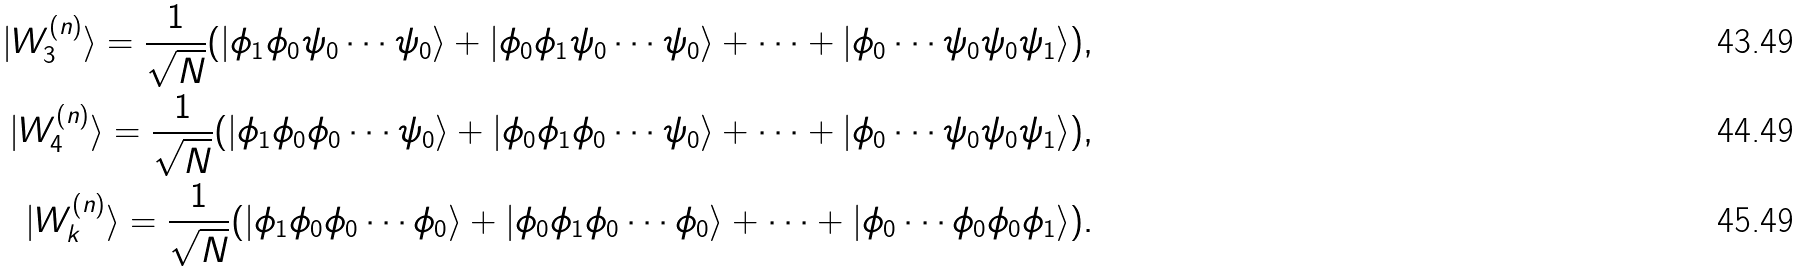Convert formula to latex. <formula><loc_0><loc_0><loc_500><loc_500>| { W } ^ { ( n ) } _ { 3 } \rangle = \frac { 1 } { \sqrt { N } } ( | \phi _ { 1 } \phi _ { 0 } \psi _ { 0 } \cdots \psi _ { 0 } \rangle + | \phi _ { 0 } \phi _ { 1 } \psi _ { 0 } \cdots \psi _ { 0 } \rangle + \cdots + | \phi _ { 0 } \cdots \psi _ { 0 } \psi _ { 0 } \psi _ { 1 } \rangle ) , \\ | { W } ^ { ( n ) } _ { 4 } \rangle = \frac { 1 } { \sqrt { N } } ( | \phi _ { 1 } \phi _ { 0 } \phi _ { 0 } \cdots \psi _ { 0 } \rangle + | \phi _ { 0 } \phi _ { 1 } \phi _ { 0 } \cdots \psi _ { 0 } \rangle + \cdots + | \phi _ { 0 } \cdots \psi _ { 0 } \psi _ { 0 } \psi _ { 1 } \rangle ) , \\ | { W } ^ { ( n ) } _ { k } \rangle = \frac { 1 } { \sqrt { N } } ( | \phi _ { 1 } \phi _ { 0 } \phi _ { 0 } \cdots \phi _ { 0 } \rangle + | \phi _ { 0 } \phi _ { 1 } \phi _ { 0 } \cdots \phi _ { 0 } \rangle + \cdots + | \phi _ { 0 } \cdots \phi _ { 0 } \phi _ { 0 } \phi _ { 1 } \rangle ) .</formula> 